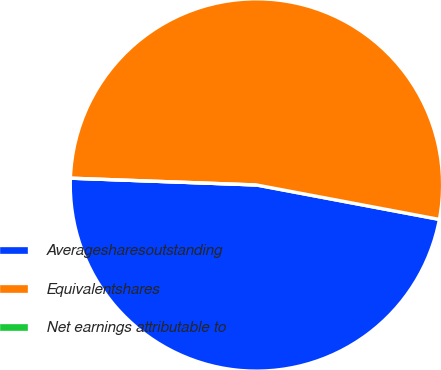<chart> <loc_0><loc_0><loc_500><loc_500><pie_chart><fcel>Averagesharesoutstanding<fcel>Equivalentshares<fcel>Net earnings attributable to<nl><fcel>47.62%<fcel>52.38%<fcel>0.0%<nl></chart> 